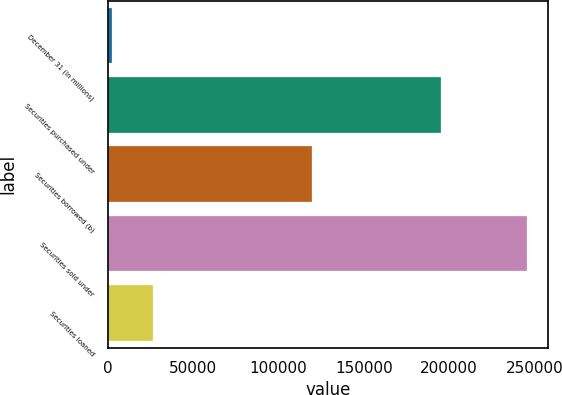Convert chart. <chart><loc_0><loc_0><loc_500><loc_500><bar_chart><fcel>December 31 (in millions)<fcel>Securities purchased under<fcel>Securities borrowed (b)<fcel>Securities sold under<fcel>Securities loaned<nl><fcel>2009<fcel>195328<fcel>119630<fcel>245692<fcel>26377.3<nl></chart> 